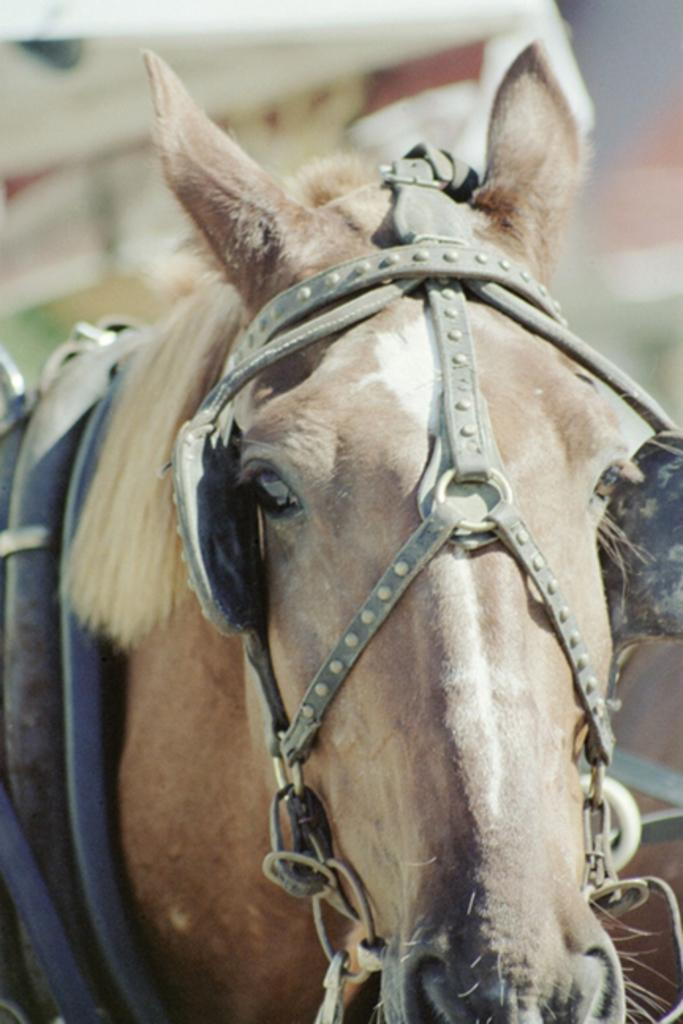What animal is present in the image? There is a horse in the image. Can you describe the background of the image? The background of the image is blurred. What type of string is being used to hold up the buildings in the downtown area of the image? There is no downtown area or buildings present in the image, and therefore no string can be observed. 